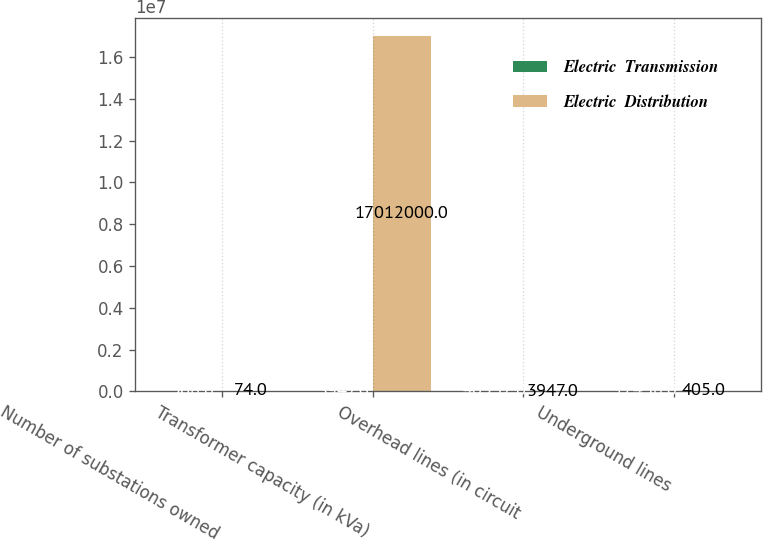Convert chart to OTSL. <chart><loc_0><loc_0><loc_500><loc_500><stacked_bar_chart><ecel><fcel>Number of substations owned<fcel>Transformer capacity (in kVa)<fcel>Overhead lines (in circuit<fcel>Underground lines<nl><fcel>Electric  Transmission<fcel>508<fcel>3947<fcel>40532<fcel>17438<nl><fcel>Electric  Distribution<fcel>74<fcel>1.7012e+07<fcel>3947<fcel>405<nl></chart> 